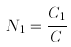Convert formula to latex. <formula><loc_0><loc_0><loc_500><loc_500>N _ { 1 } = \frac { C _ { 1 } } { C }</formula> 